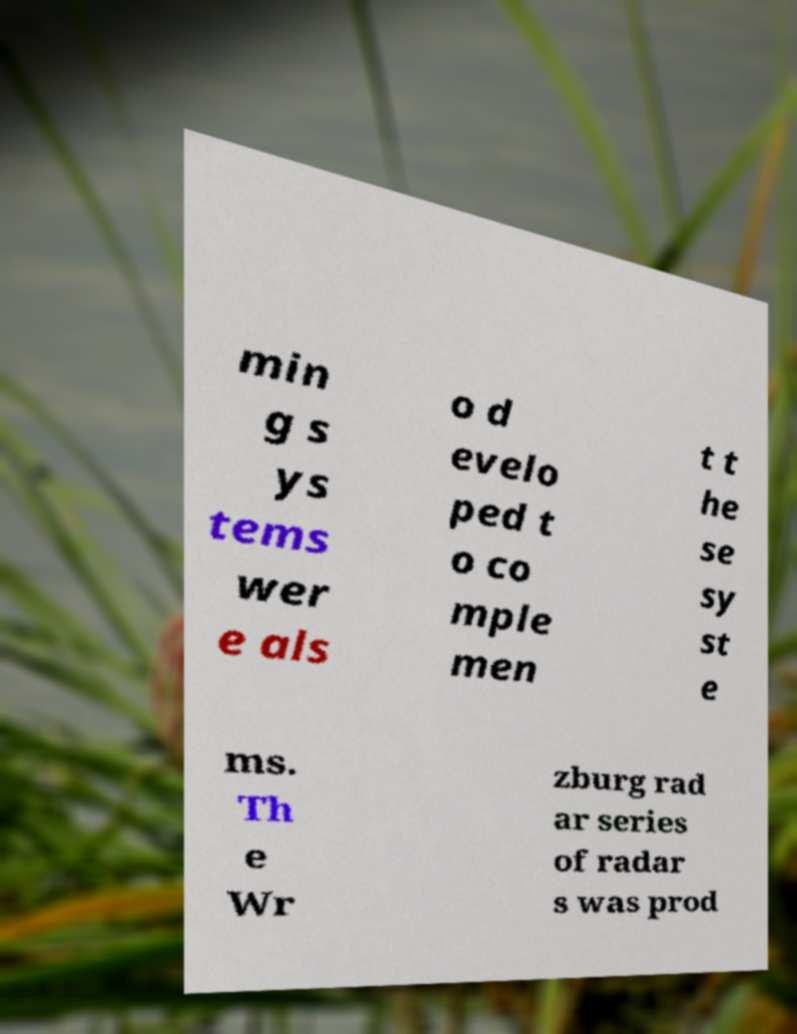Could you assist in decoding the text presented in this image and type it out clearly? min g s ys tems wer e als o d evelo ped t o co mple men t t he se sy st e ms. Th e Wr zburg rad ar series of radar s was prod 